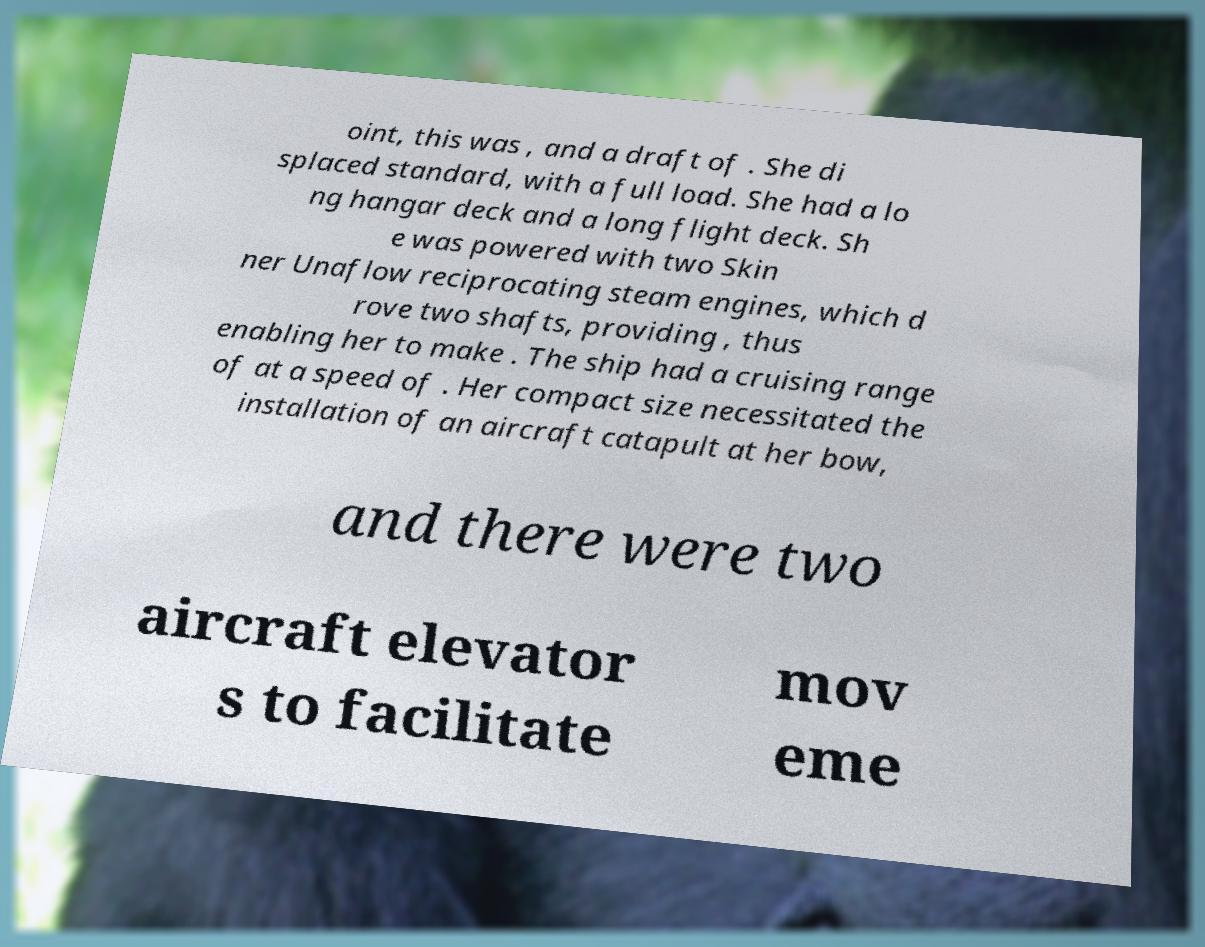What messages or text are displayed in this image? I need them in a readable, typed format. oint, this was , and a draft of . She di splaced standard, with a full load. She had a lo ng hangar deck and a long flight deck. Sh e was powered with two Skin ner Unaflow reciprocating steam engines, which d rove two shafts, providing , thus enabling her to make . The ship had a cruising range of at a speed of . Her compact size necessitated the installation of an aircraft catapult at her bow, and there were two aircraft elevator s to facilitate mov eme 